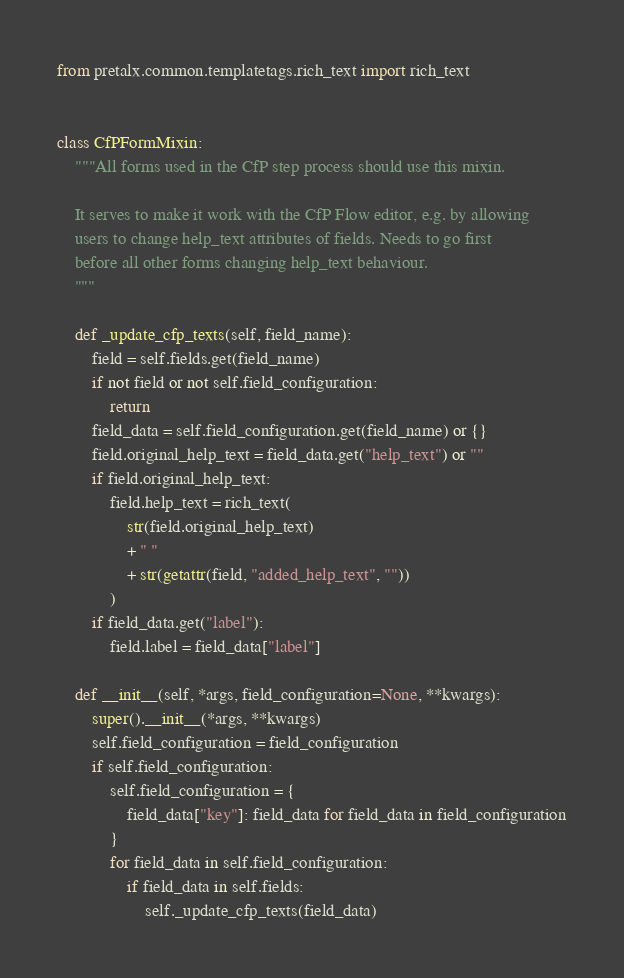Convert code to text. <code><loc_0><loc_0><loc_500><loc_500><_Python_>from pretalx.common.templatetags.rich_text import rich_text


class CfPFormMixin:
    """All forms used in the CfP step process should use this mixin.

    It serves to make it work with the CfP Flow editor, e.g. by allowing
    users to change help_text attributes of fields. Needs to go first
    before all other forms changing help_text behaviour.
    """

    def _update_cfp_texts(self, field_name):
        field = self.fields.get(field_name)
        if not field or not self.field_configuration:
            return
        field_data = self.field_configuration.get(field_name) or {}
        field.original_help_text = field_data.get("help_text") or ""
        if field.original_help_text:
            field.help_text = rich_text(
                str(field.original_help_text)
                + " "
                + str(getattr(field, "added_help_text", ""))
            )
        if field_data.get("label"):
            field.label = field_data["label"]

    def __init__(self, *args, field_configuration=None, **kwargs):
        super().__init__(*args, **kwargs)
        self.field_configuration = field_configuration
        if self.field_configuration:
            self.field_configuration = {
                field_data["key"]: field_data for field_data in field_configuration
            }
            for field_data in self.field_configuration:
                if field_data in self.fields:
                    self._update_cfp_texts(field_data)
</code> 